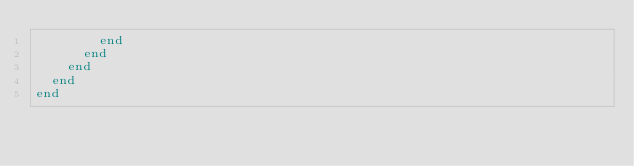<code> <loc_0><loc_0><loc_500><loc_500><_Ruby_>        end
      end
    end
  end
end
</code> 